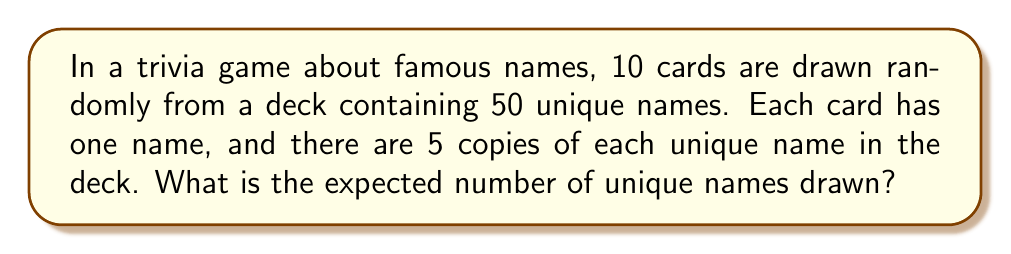Give your solution to this math problem. Let's approach this step-by-step:

1) First, we need to understand that this is a problem of finding the expected value of a random variable. The random variable here is the number of unique names drawn.

2) We can use the linearity of expectation. Let $X_i$ be an indicator variable for the $i$-th unique name, where:
   $X_i = 1$ if the $i$-th name is drawn at least once
   $X_i = 0$ otherwise

3) The expected number of unique names is then:
   $E[X] = E[X_1 + X_2 + ... + X_{50}] = E[X_1] + E[X_2] + ... + E[X_{50}]$

4) For each $X_i$, the probability of not drawing the name is:
   $P(X_i = 0) = \left(\frac{45}{50}\right)^{10}$

   This is because for each draw, the probability of not getting this name is $\frac{45}{50}$, and we do this 10 times independently.

5) Therefore, the probability of drawing the name at least once is:
   $P(X_i = 1) = 1 - \left(\frac{45}{50}\right)^{10}$

6) The expected value of each $X_i$ is:
   $E[X_i] = 1 \cdot P(X_i = 1) + 0 \cdot P(X_i = 0) = 1 - \left(\frac{45}{50}\right)^{10}$

7) Since there are 50 unique names, the total expected value is:
   $E[X] = 50 \cdot \left(1 - \left(\frac{45}{50}\right)^{10}\right)$

8) Calculating this:
   $E[X] = 50 \cdot (1 - (0.9)^{10}) \approx 50 \cdot (1 - 0.3487) \approx 32.565$
Answer: $32.565$ unique names 